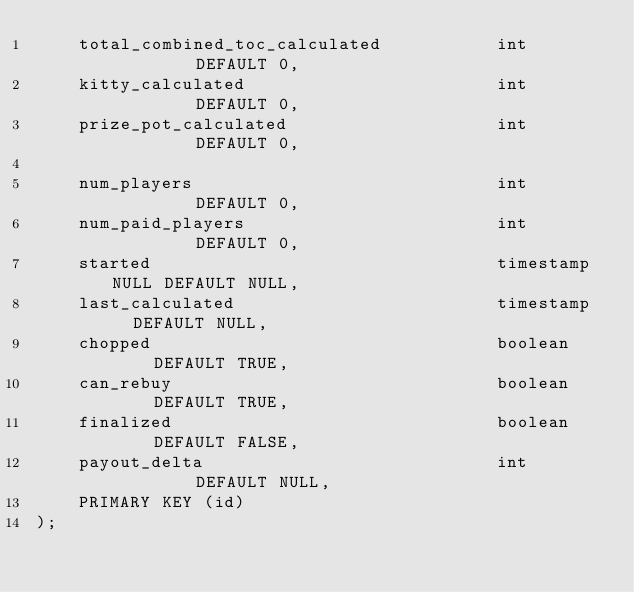<code> <loc_0><loc_0><loc_500><loc_500><_SQL_>    total_combined_toc_calculated           int         DEFAULT 0,
    kitty_calculated                        int         DEFAULT 0,
    prize_pot_calculated                    int         DEFAULT 0,

    num_players                             int         DEFAULT 0,
    num_paid_players                        int         DEFAULT 0,
    started                                 timestamp NULL DEFAULT NULL,
    last_calculated                         timestamp   DEFAULT NULL,
    chopped                                 boolean     DEFAULT TRUE,
    can_rebuy                               boolean     DEFAULT TRUE,
    finalized                               boolean     DEFAULT FALSE,
    payout_delta                            int         DEFAULT NULL,
    PRIMARY KEY (id)
);
</code> 